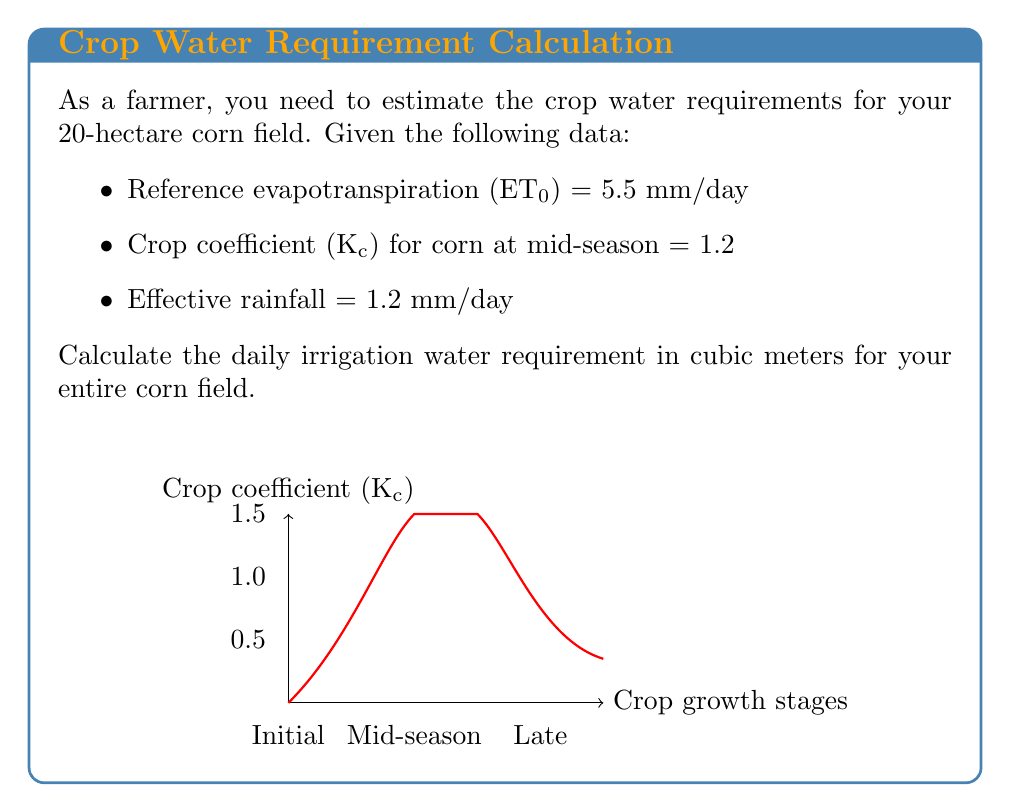Show me your answer to this math problem. To solve this problem, we'll follow these steps:

1) Calculate the crop evapotranspiration (ETc):
   ETc = ET₀ * Kc
   $$ETc = 5.5 \frac{mm}{day} * 1.2 = 6.6 \frac{mm}{day}$$

2) Calculate the net irrigation requirement (NIR):
   NIR = ETc - Effective rainfall
   $$NIR = 6.6 \frac{mm}{day} - 1.2 \frac{mm}{day} = 5.4 \frac{mm}{day}$$

3) Convert NIR from mm/day to m/day:
   $$5.4 \frac{mm}{day} * \frac{1 m}{1000 mm} = 0.0054 \frac{m}{day}$$

4) Calculate the volume of water needed for the entire field:
   Volume = NIR * Area
   $$Volume = 0.0054 \frac{m}{day} * 20 \text{ hectares} * \frac{10000 m^2}{1 \text{ hectare}} = 1080 \frac{m^3}{day}$$

Therefore, the daily irrigation water requirement for the entire corn field is 1080 cubic meters.
Answer: 1080 m³/day 